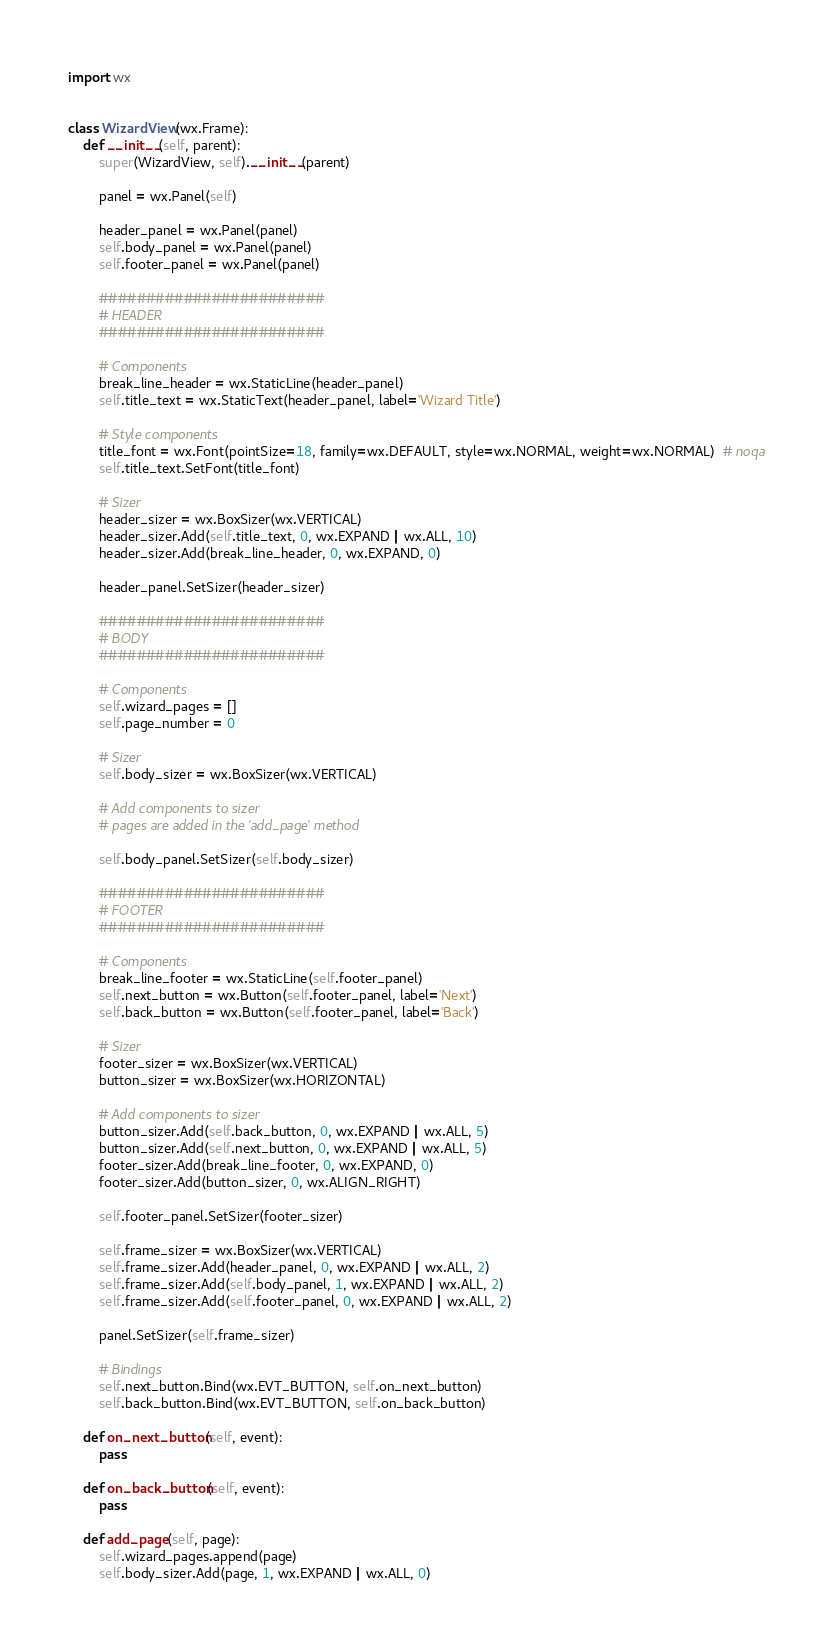Convert code to text. <code><loc_0><loc_0><loc_500><loc_500><_Python_>import wx


class WizardView(wx.Frame):
    def __init__(self, parent):
        super(WizardView, self).__init__(parent)

        panel = wx.Panel(self)

        header_panel = wx.Panel(panel)
        self.body_panel = wx.Panel(panel)
        self.footer_panel = wx.Panel(panel)

        ########################
        # HEADER
        ########################

        # Components
        break_line_header = wx.StaticLine(header_panel)
        self.title_text = wx.StaticText(header_panel, label='Wizard Title')

        # Style components
        title_font = wx.Font(pointSize=18, family=wx.DEFAULT, style=wx.NORMAL, weight=wx.NORMAL)  # noqa
        self.title_text.SetFont(title_font)

        # Sizer
        header_sizer = wx.BoxSizer(wx.VERTICAL)
        header_sizer.Add(self.title_text, 0, wx.EXPAND | wx.ALL, 10)
        header_sizer.Add(break_line_header, 0, wx.EXPAND, 0)

        header_panel.SetSizer(header_sizer)

        ########################
        # BODY
        ########################

        # Components
        self.wizard_pages = []
        self.page_number = 0

        # Sizer
        self.body_sizer = wx.BoxSizer(wx.VERTICAL)

        # Add components to sizer
        # pages are added in the 'add_page' method

        self.body_panel.SetSizer(self.body_sizer)

        ########################
        # FOOTER
        ########################

        # Components
        break_line_footer = wx.StaticLine(self.footer_panel)
        self.next_button = wx.Button(self.footer_panel, label='Next')
        self.back_button = wx.Button(self.footer_panel, label='Back')

        # Sizer
        footer_sizer = wx.BoxSizer(wx.VERTICAL)
        button_sizer = wx.BoxSizer(wx.HORIZONTAL)

        # Add components to sizer
        button_sizer.Add(self.back_button, 0, wx.EXPAND | wx.ALL, 5)
        button_sizer.Add(self.next_button, 0, wx.EXPAND | wx.ALL, 5)
        footer_sizer.Add(break_line_footer, 0, wx.EXPAND, 0)
        footer_sizer.Add(button_sizer, 0, wx.ALIGN_RIGHT)

        self.footer_panel.SetSizer(footer_sizer)

        self.frame_sizer = wx.BoxSizer(wx.VERTICAL)
        self.frame_sizer.Add(header_panel, 0, wx.EXPAND | wx.ALL, 2)
        self.frame_sizer.Add(self.body_panel, 1, wx.EXPAND | wx.ALL, 2)
        self.frame_sizer.Add(self.footer_panel, 0, wx.EXPAND | wx.ALL, 2)

        panel.SetSizer(self.frame_sizer)

        # Bindings
        self.next_button.Bind(wx.EVT_BUTTON, self.on_next_button)
        self.back_button.Bind(wx.EVT_BUTTON, self.on_back_button)

    def on_next_button(self, event):
        pass

    def on_back_button(self, event):
        pass

    def add_page(self, page):
        self.wizard_pages.append(page)
        self.body_sizer.Add(page, 1, wx.EXPAND | wx.ALL, 0)
</code> 